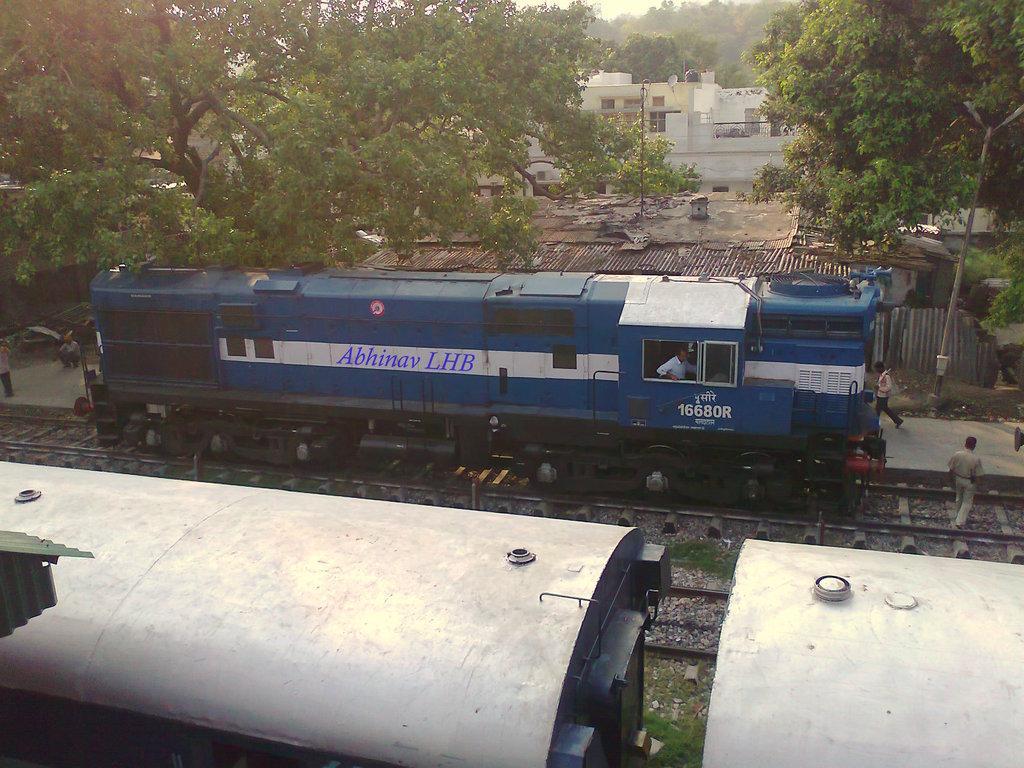How would you summarize this image in a sentence or two? In this picture we can see trains on the railway track and some people walking on the path. Behind the trains there are buildings, trees and a sky. 